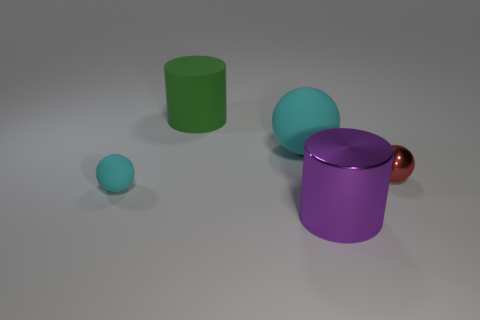Subtract all rubber spheres. How many spheres are left? 1 Add 1 small rubber spheres. How many objects exist? 6 Subtract all yellow cylinders. How many cyan spheres are left? 2 Subtract all cyan spheres. How many spheres are left? 1 Subtract 2 cylinders. How many cylinders are left? 0 Subtract all balls. How many objects are left? 2 Subtract 0 brown cubes. How many objects are left? 5 Subtract all green balls. Subtract all yellow cylinders. How many balls are left? 3 Subtract all purple shiny things. Subtract all small purple cylinders. How many objects are left? 4 Add 5 large cyan rubber spheres. How many large cyan rubber spheres are left? 6 